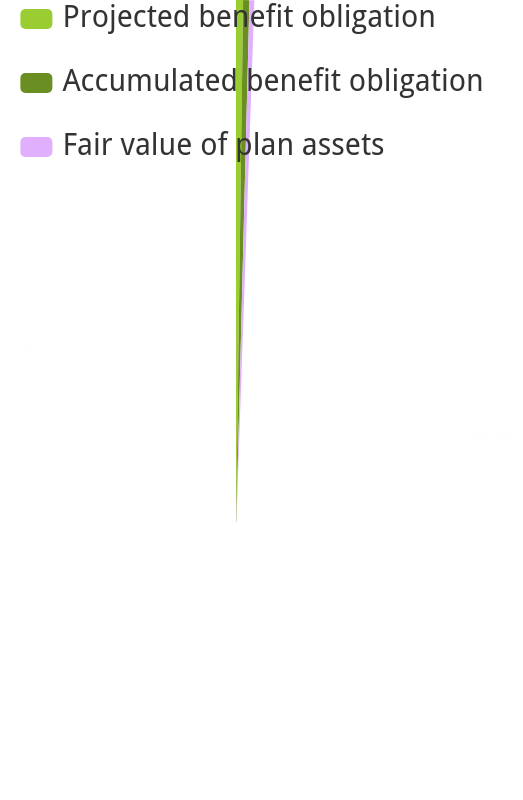Convert chart to OTSL. <chart><loc_0><loc_0><loc_500><loc_500><pie_chart><fcel>Projected benefit obligation<fcel>Accumulated benefit obligation<fcel>Fair value of plan assets<nl><fcel>38.86%<fcel>34.5%<fcel>26.64%<nl></chart> 